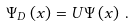<formula> <loc_0><loc_0><loc_500><loc_500>\Psi _ { D } \left ( x \right ) = U \Psi \left ( x \right ) \, .</formula> 